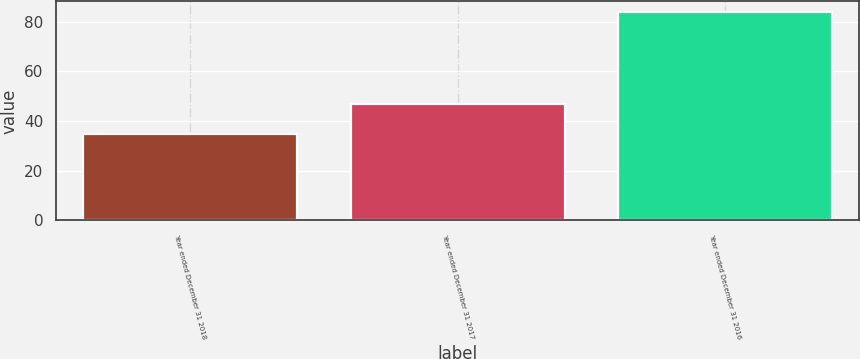Convert chart. <chart><loc_0><loc_0><loc_500><loc_500><bar_chart><fcel>Year ended December 31 2018<fcel>Year ended December 31 2017<fcel>Year ended December 31 2016<nl><fcel>35<fcel>47<fcel>84<nl></chart> 